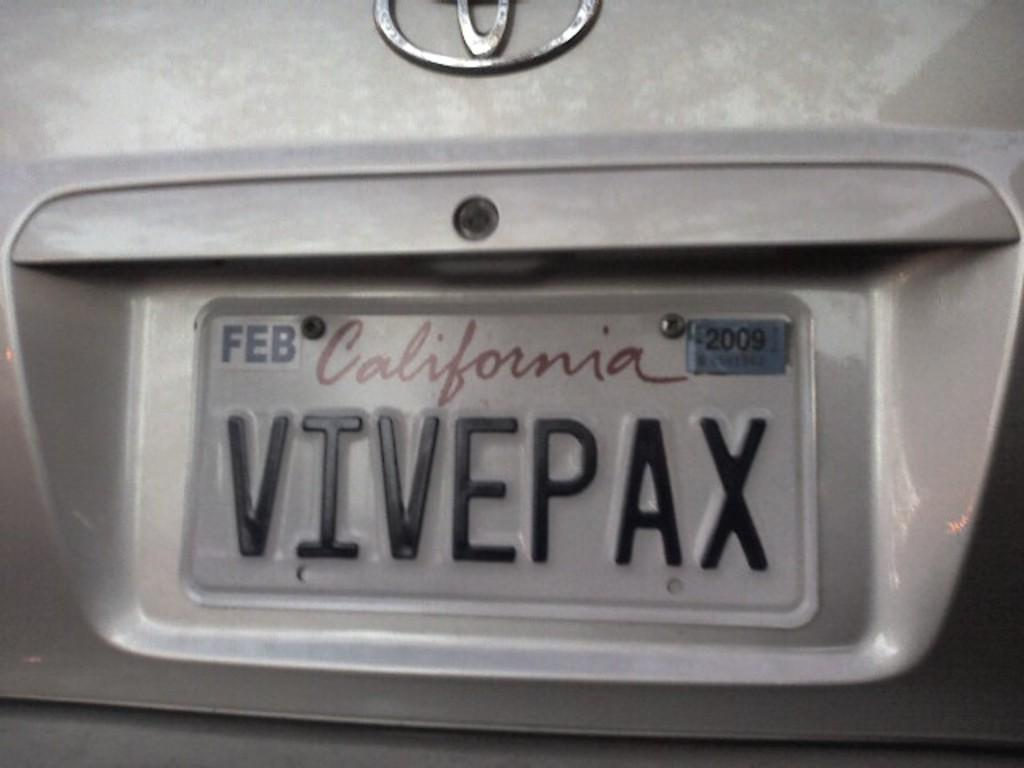<image>
Describe the image concisely. A silver Toyota with a California tag reading VIVEPAX. 